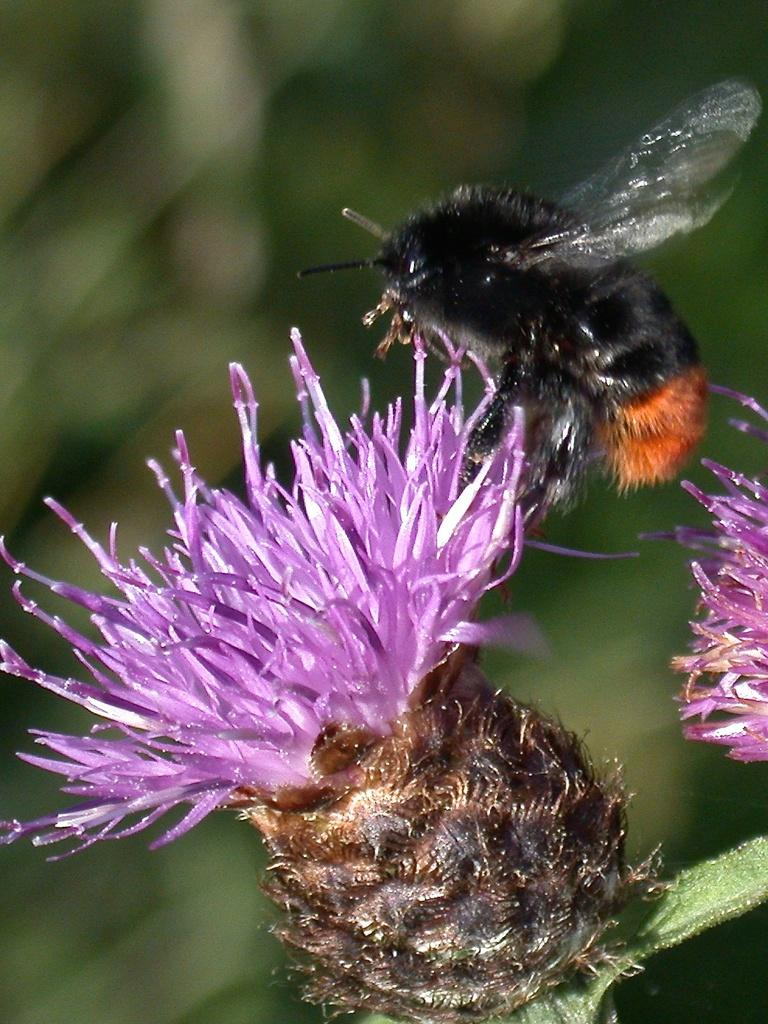What is the main subject of the image? The main subject of the image is an insect on a flower. Can you describe the background of the image? The background of the image is blurred. How many mines are visible in the image? There are no mines present in the image. What type of geese can be seen in the image? There are no geese present in the image. 